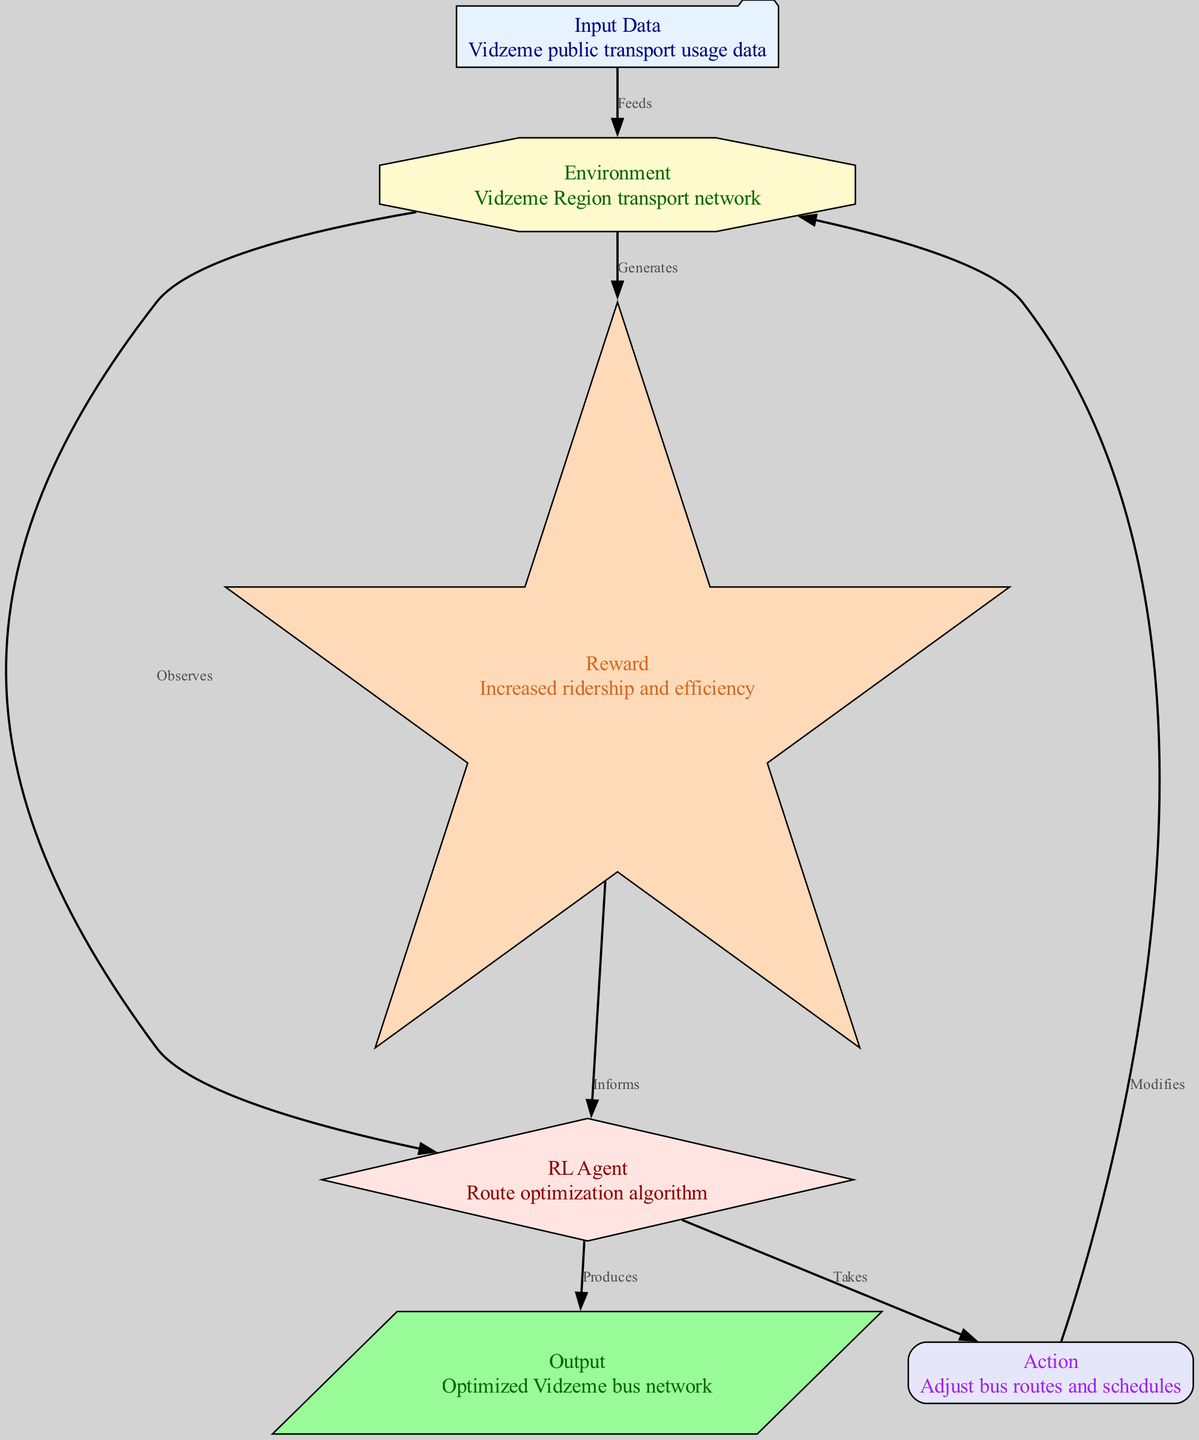What is the first node in the diagram? The first node shown in the diagram is labeled "Input Data." It is at the top of the diagram, indicating the starting point of the process.
Answer: Input Data How many nodes are present in the diagram? By counting the nodes presented in the diagram's data, we find there are six distinct nodes: Input Data, Environment, RL Agent, Action, Reward, and Output.
Answer: Six What does the RL Agent do in the process? The RL Agent takes actions based on the observations from the Environment. This interaction is shown by an edge connecting the agent to the action node.
Answer: Takes What is the relationship between the Environment and Reward nodes? The Environment generates the Reward as indicated by the directed edge connecting these two nodes. This means the Environment produces the value that contributes to the learning process.
Answer: Generates How is the Output node related to the RL Agent? The Output node is produced by the RL Agent as indicated by the directed arrow connecting these two nodes. This signifies that the agent's actions culminate in the final output of the optimized bus network.
Answer: Produces What type of action does the agent take? The action taken by the RL Agent is to adjust bus routes and schedules, as indicated by the label of the action node following the edge leading from the agent.
Answer: Adjust bus routes and schedules Which node informs the RL Agent and how? The Reward node informs the RL Agent, as indicated by the directed edge going from the Reward node back to the RL Agent. This feedback is crucial for the agent to learn and optimize its actions.
Answer: Informs What is the reward for optimizing the routes? The reward for optimizing the bus routes is described as increased ridership and efficiency, which is noted in the details of the Reward node.
Answer: Increased ridership and efficiency 